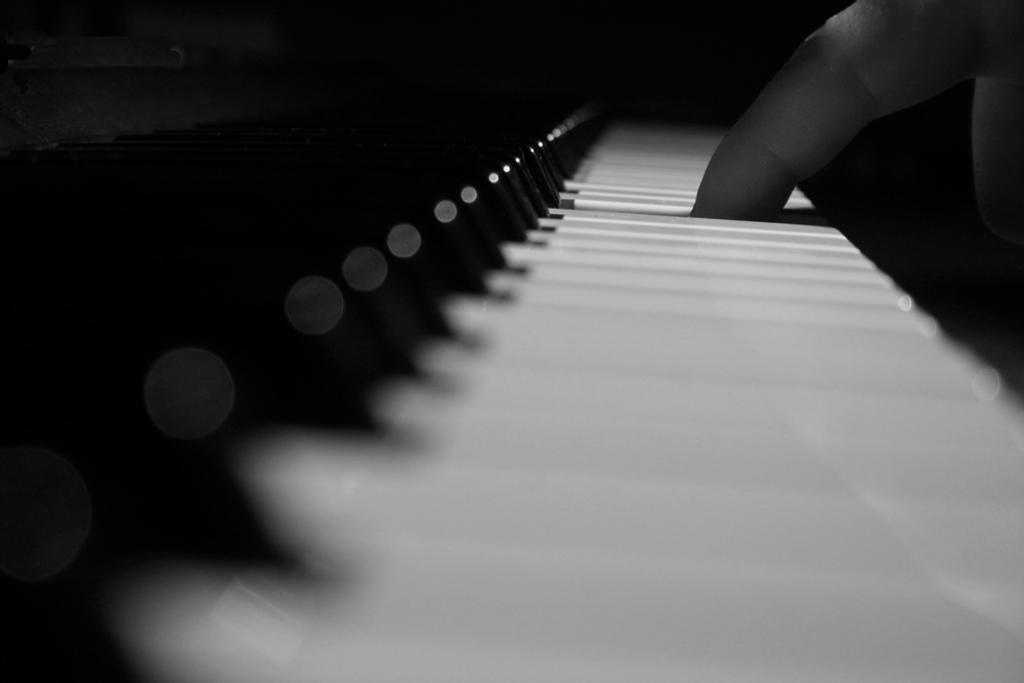What musical instrument is present in the image? There is a piano in the image. What feature of the piano is visible in the image? The piano has keys. What is the person in the image doing? The person is clicking the piano. What type of story is the person telling to the donkey in the image? There is no donkey present in the image, and therefore no such interaction can be observed. 